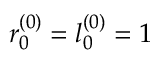Convert formula to latex. <formula><loc_0><loc_0><loc_500><loc_500>r _ { 0 } ^ { ( 0 ) } = l _ { 0 } ^ { ( 0 ) } = 1</formula> 